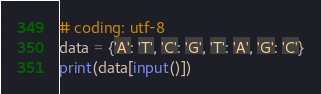<code> <loc_0><loc_0><loc_500><loc_500><_Python_># coding: utf-8
data = {'A': 'T', 'C': 'G', 'T': 'A', 'G': 'C'}
print(data[input()])
</code> 